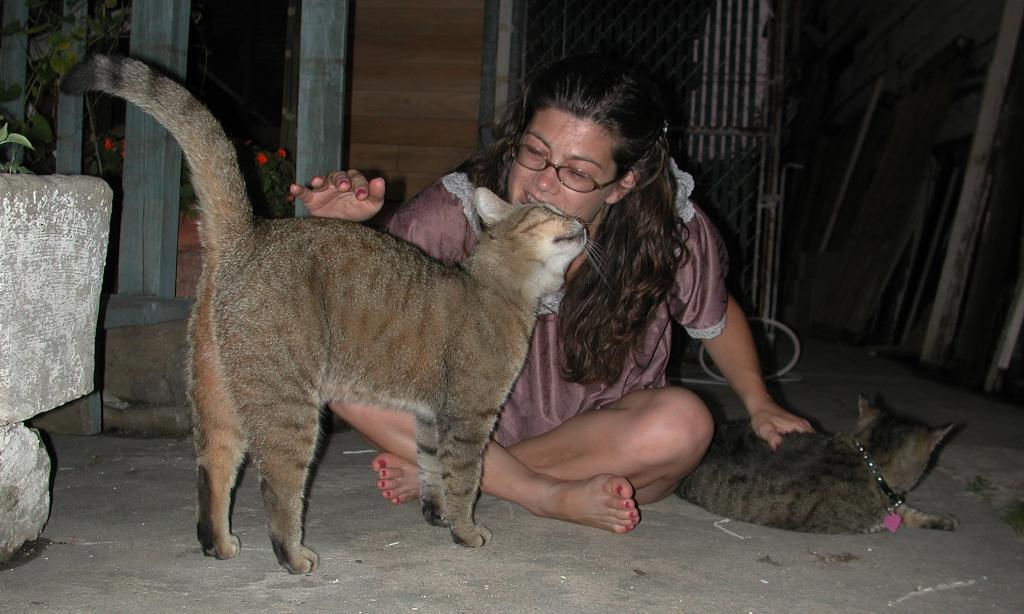What is the person in the image doing? The person is sitting on the floor and looking at a cat. How many cats can be seen in the image? There is at least one cat in the image. What type of vegetation is present in the image? There are plants in the image. What is the person likely to be using for cooking? There is a grill in the image, which might be used for cooking. What is the material of the wall in the image? There is a wooden wall in the image. Can you describe the objects in the image? There are objects in the image, but their specific nature is not mentioned in the facts. What type of letter is the person holding in the image? There is no mention of a letter in the image, so it cannot be determined if the person is holding one. 